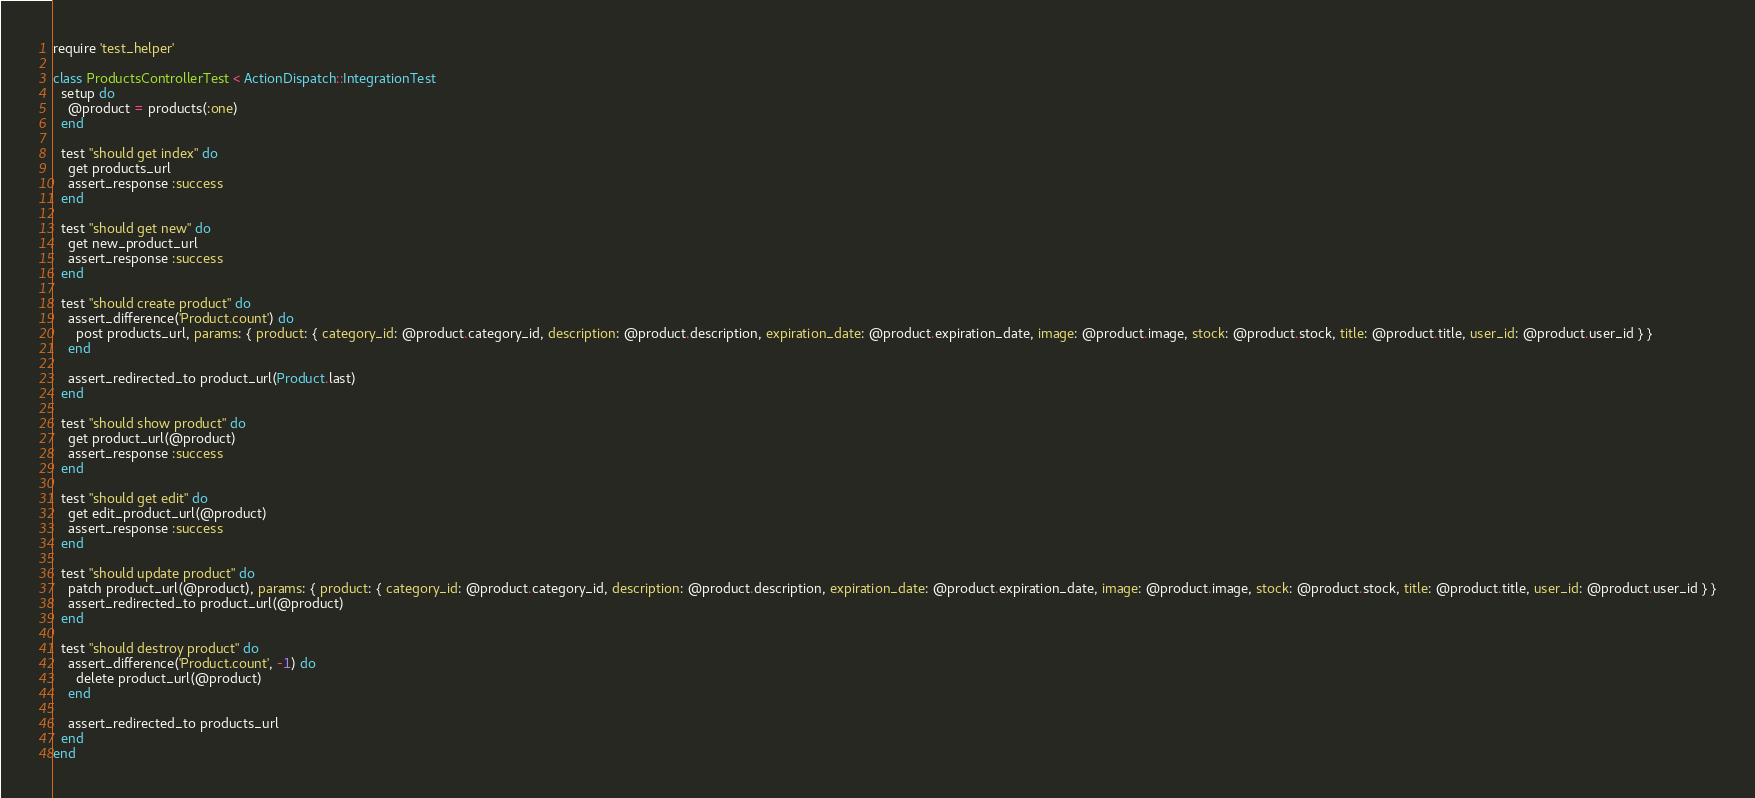<code> <loc_0><loc_0><loc_500><loc_500><_Ruby_>require 'test_helper'

class ProductsControllerTest < ActionDispatch::IntegrationTest
  setup do
    @product = products(:one)
  end

  test "should get index" do
    get products_url
    assert_response :success
  end

  test "should get new" do
    get new_product_url
    assert_response :success
  end

  test "should create product" do
    assert_difference('Product.count') do
      post products_url, params: { product: { category_id: @product.category_id, description: @product.description, expiration_date: @product.expiration_date, image: @product.image, stock: @product.stock, title: @product.title, user_id: @product.user_id } }
    end

    assert_redirected_to product_url(Product.last)
  end

  test "should show product" do
    get product_url(@product)
    assert_response :success
  end

  test "should get edit" do
    get edit_product_url(@product)
    assert_response :success
  end

  test "should update product" do
    patch product_url(@product), params: { product: { category_id: @product.category_id, description: @product.description, expiration_date: @product.expiration_date, image: @product.image, stock: @product.stock, title: @product.title, user_id: @product.user_id } }
    assert_redirected_to product_url(@product)
  end

  test "should destroy product" do
    assert_difference('Product.count', -1) do
      delete product_url(@product)
    end

    assert_redirected_to products_url
  end
end
</code> 